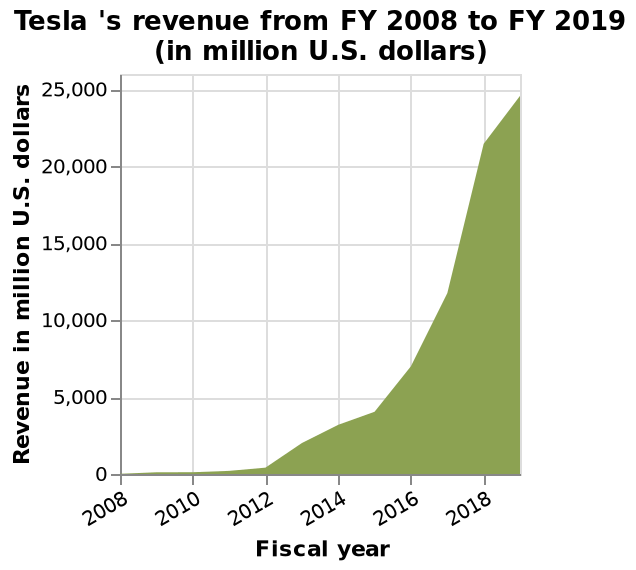<image>
What is the title of the area chart?  The area chart is titled "Tesla's revenue from FY 2008 to FY 2019 (in million U.S. dollars)." What can be said about the subject's rise in recent years? The subject has risen dramatically in recent years, particularly from 2015 onwards. What is the time range depicted on the x-axis of the area chart? The time range depicted on the x-axis of the area chart is from fiscal year 2008 to fiscal year 2019. 